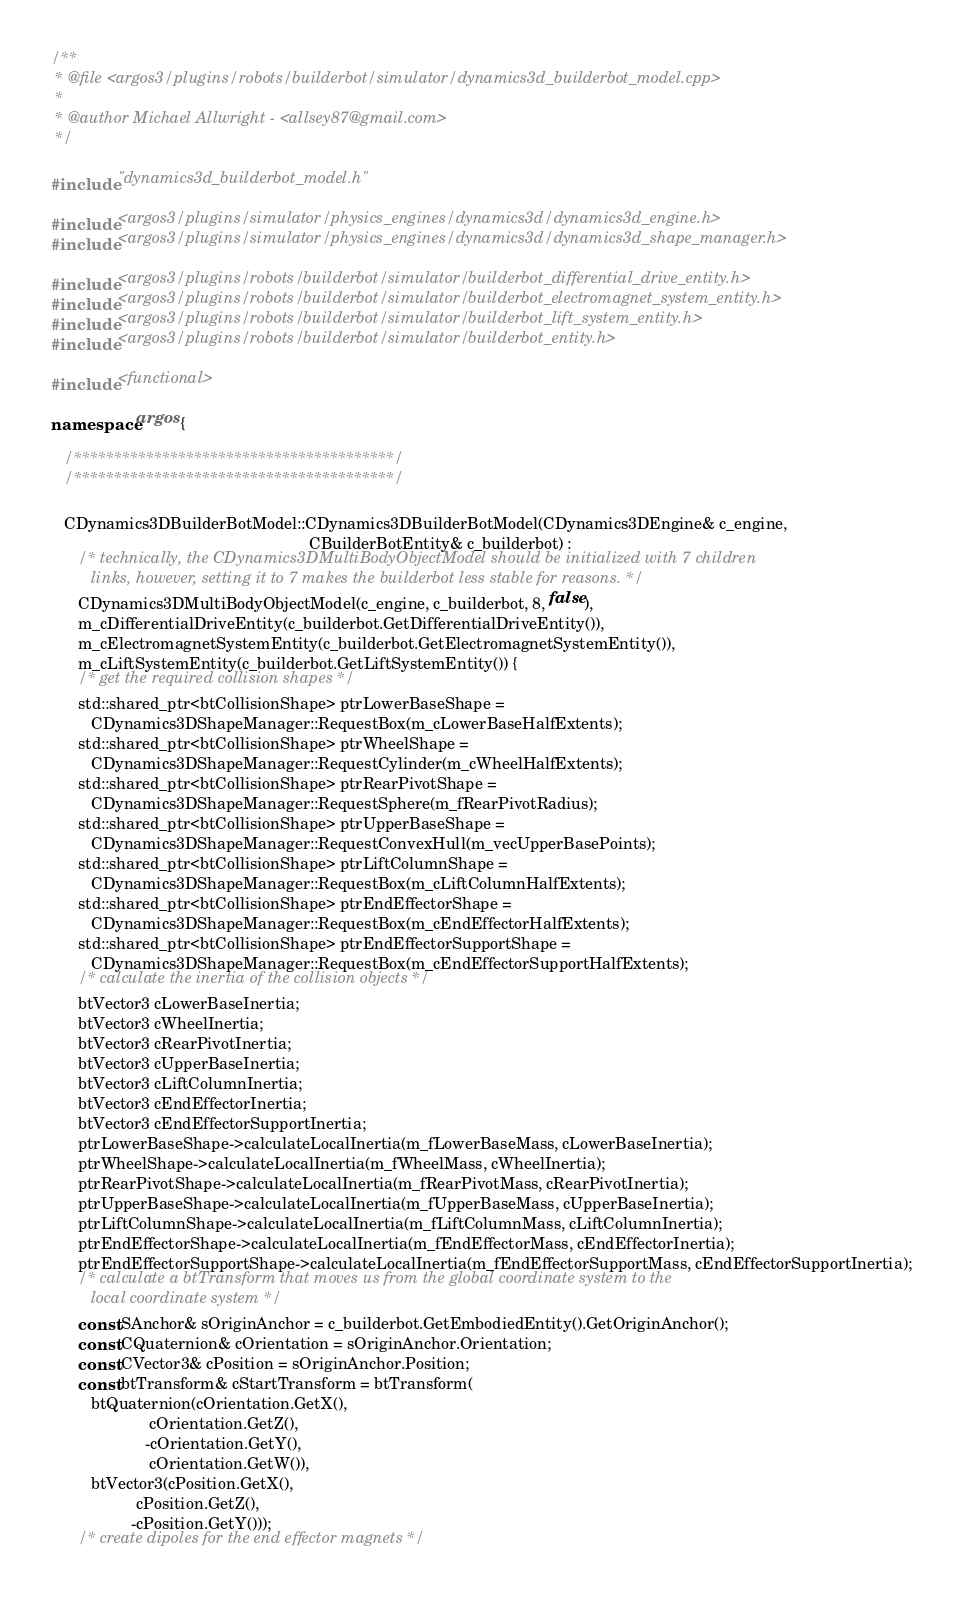<code> <loc_0><loc_0><loc_500><loc_500><_C++_>/**
 * @file <argos3/plugins/robots/builderbot/simulator/dynamics3d_builderbot_model.cpp>
 *
 * @author Michael Allwright - <allsey87@gmail.com>
 */

#include "dynamics3d_builderbot_model.h"

#include <argos3/plugins/simulator/physics_engines/dynamics3d/dynamics3d_engine.h>
#include <argos3/plugins/simulator/physics_engines/dynamics3d/dynamics3d_shape_manager.h>

#include <argos3/plugins/robots/builderbot/simulator/builderbot_differential_drive_entity.h>
#include <argos3/plugins/robots/builderbot/simulator/builderbot_electromagnet_system_entity.h>
#include <argos3/plugins/robots/builderbot/simulator/builderbot_lift_system_entity.h>
#include <argos3/plugins/robots/builderbot/simulator/builderbot_entity.h>

#include <functional>

namespace argos {

   /****************************************/
   /****************************************/

   CDynamics3DBuilderBotModel::CDynamics3DBuilderBotModel(CDynamics3DEngine& c_engine,
                                                          CBuilderBotEntity& c_builderbot) :
      /* technically, the CDynamics3DMultiBodyObjectModel should be initialized with 7 children
         links, however, setting it to 7 makes the builderbot less stable for reasons. */
      CDynamics3DMultiBodyObjectModel(c_engine, c_builderbot, 8, false),
      m_cDifferentialDriveEntity(c_builderbot.GetDifferentialDriveEntity()),
      m_cElectromagnetSystemEntity(c_builderbot.GetElectromagnetSystemEntity()),
      m_cLiftSystemEntity(c_builderbot.GetLiftSystemEntity()) {
      /* get the required collision shapes */
      std::shared_ptr<btCollisionShape> ptrLowerBaseShape =
         CDynamics3DShapeManager::RequestBox(m_cLowerBaseHalfExtents);
      std::shared_ptr<btCollisionShape> ptrWheelShape =
         CDynamics3DShapeManager::RequestCylinder(m_cWheelHalfExtents);
      std::shared_ptr<btCollisionShape> ptrRearPivotShape =
         CDynamics3DShapeManager::RequestSphere(m_fRearPivotRadius);
      std::shared_ptr<btCollisionShape> ptrUpperBaseShape =
         CDynamics3DShapeManager::RequestConvexHull(m_vecUpperBasePoints);
      std::shared_ptr<btCollisionShape> ptrLiftColumnShape =
         CDynamics3DShapeManager::RequestBox(m_cLiftColumnHalfExtents);
      std::shared_ptr<btCollisionShape> ptrEndEffectorShape =
         CDynamics3DShapeManager::RequestBox(m_cEndEffectorHalfExtents);
      std::shared_ptr<btCollisionShape> ptrEndEffectorSupportShape =
         CDynamics3DShapeManager::RequestBox(m_cEndEffectorSupportHalfExtents);
      /* calculate the inertia of the collision objects */
      btVector3 cLowerBaseInertia;
      btVector3 cWheelInertia;
      btVector3 cRearPivotInertia;
      btVector3 cUpperBaseInertia;
      btVector3 cLiftColumnInertia;
      btVector3 cEndEffectorInertia;
      btVector3 cEndEffectorSupportInertia;
      ptrLowerBaseShape->calculateLocalInertia(m_fLowerBaseMass, cLowerBaseInertia);
      ptrWheelShape->calculateLocalInertia(m_fWheelMass, cWheelInertia);
      ptrRearPivotShape->calculateLocalInertia(m_fRearPivotMass, cRearPivotInertia);
      ptrUpperBaseShape->calculateLocalInertia(m_fUpperBaseMass, cUpperBaseInertia);
      ptrLiftColumnShape->calculateLocalInertia(m_fLiftColumnMass, cLiftColumnInertia);
      ptrEndEffectorShape->calculateLocalInertia(m_fEndEffectorMass, cEndEffectorInertia);
      ptrEndEffectorSupportShape->calculateLocalInertia(m_fEndEffectorSupportMass, cEndEffectorSupportInertia);
      /* calculate a btTransform that moves us from the global coordinate system to the
         local coordinate system */
      const SAnchor& sOriginAnchor = c_builderbot.GetEmbodiedEntity().GetOriginAnchor();
      const CQuaternion& cOrientation = sOriginAnchor.Orientation;
      const CVector3& cPosition = sOriginAnchor.Position;     
      const btTransform& cStartTransform = btTransform(
         btQuaternion(cOrientation.GetX(),
                      cOrientation.GetZ(),
                     -cOrientation.GetY(),
                      cOrientation.GetW()),
         btVector3(cPosition.GetX(),
                   cPosition.GetZ(),
                  -cPosition.GetY()));
      /* create dipoles for the end effector magnets */</code> 